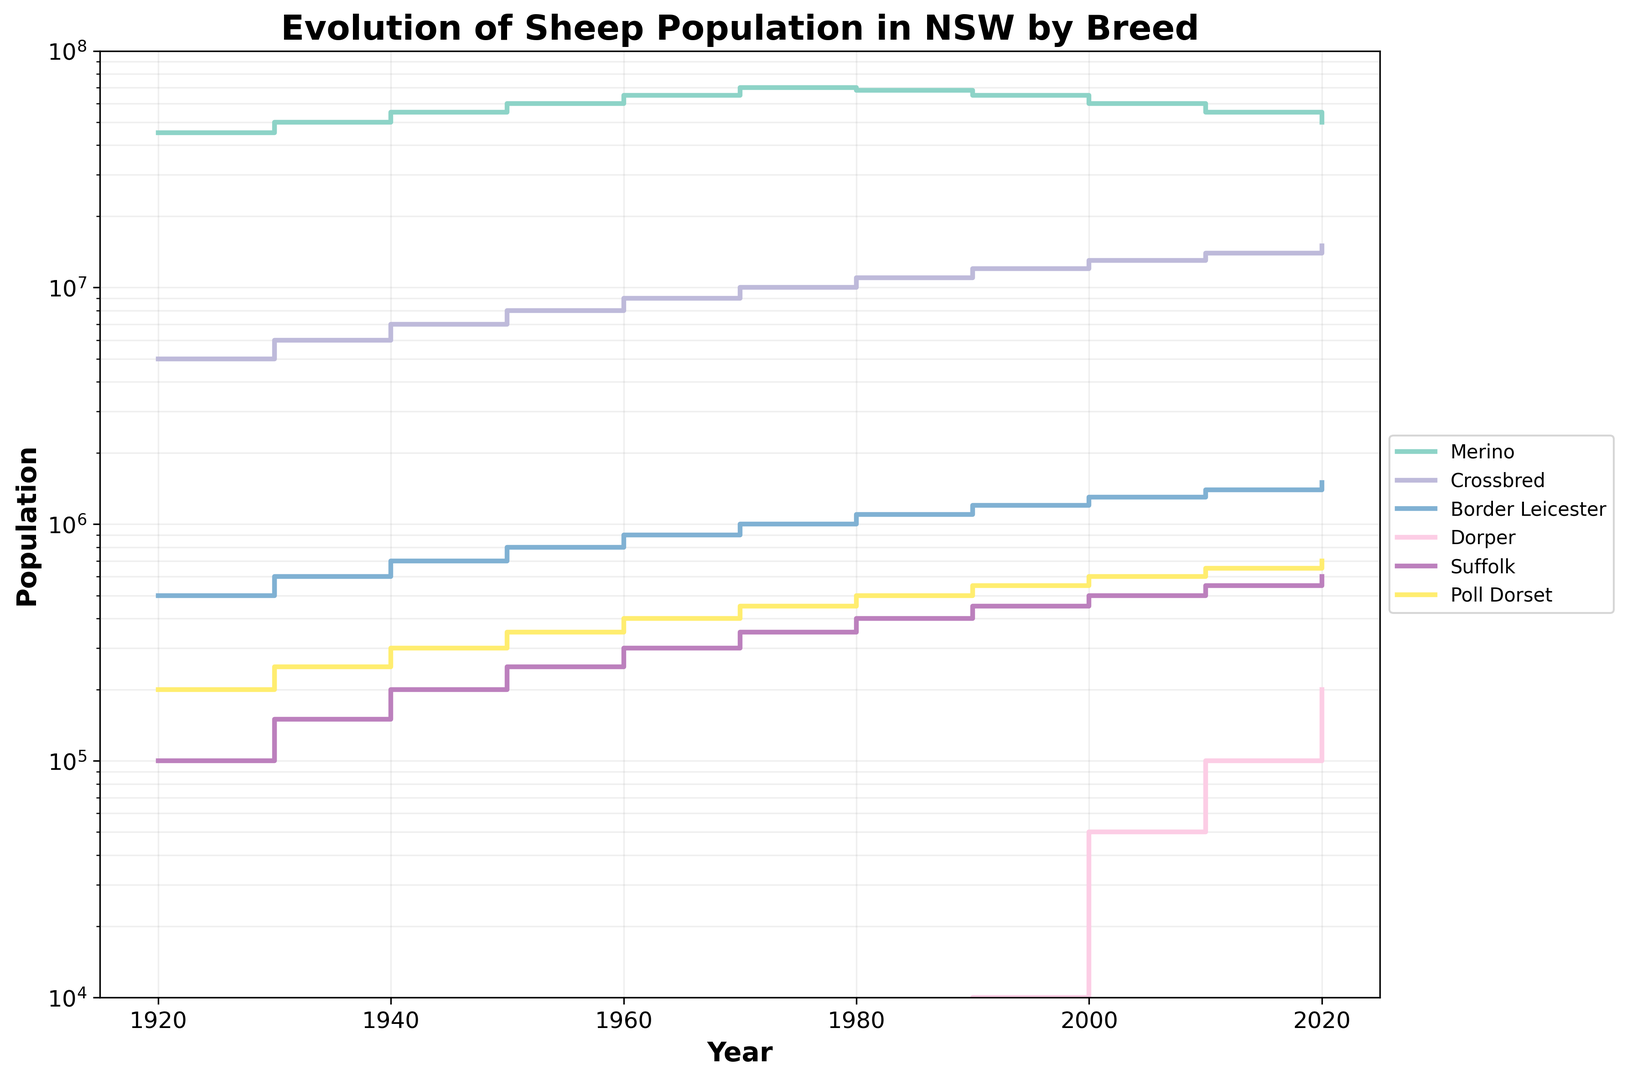What's the population trend of the Merino breed from 1920 to 2020? To understand the Merino population trend, we need to analyze its fluctuations over time. From 1920 to 1970, the population steadily increased. Then, between 1970 and 1980, it experienced a slight decline, followed by a continuing decline till 2020.
Answer: Generally decreasing after 1970 Which breed had the most significant population increase from 1920 to 2020? To determine this, we should calculate the population change for each breed. For instance, the Merino went from 45 million to 50 million, a 5 million increase. The Crossbred went from 5 million to 15 million, a 10 million increase. Comparing all breeds, the Crossbred had the largest increase of 10 million.
Answer: Crossbred In which decade did the Border Leicester breed first appear in the data? To find out when the Border Leicester breed first appears, we should look for the first non-zero value in its population data. The first non-zero value is recorded in 1920.
Answer: 1920 Given the population changes, are there any breeds that did not exist in 1920 but appear later? By checking the 1920 data, neither Dorper nor Poll Dorset had any population recorded. They first appear later, with Dorper starting in 1990 and Poll Dorset present from 1920.
Answer: Dorper How does the population of the Suffolk breed in 2020 compare to 1980? We need to compare the Suffolk population in 1980 (400,000) against its population in 2020 (600,000). To do this, we subtract the 1980 population from the 2020 population to find the increase.
Answer: Increased by 200,000 What is the average population of the Crossbred breed between 1920 and 2020? To calculate the average population of the Crossbred breed, sum the populations from each decade and divide by the number of decades (11). The sum is (5M+6M+7M+8M+9M+10M+11M+12M+13M+14M+15M) = 100M, then divide by 11.
Answer: 9,090,909 Which breed saw its population peak in 1970 and subsequently decline? We look at each breed's population at the 1970 mark and see if their subsequent population declined. Both the Merino peaked at 70 million in 1970 and then declined.
Answer: Merino How does the population of the Poll Dorset in the first half of the century (1920-1970) compare to the second half (1970-2020)? For the Poll Dorset, sum the populations from 1920 to 1970 and from 1970 to 2020. The populations are zero in 1920-1970, and post-1970 it's 450K + 500K + 550K + 600K + 650K + 700K = 3450K.
Answer: Increased Which breed had a steady increase without any period of decline from 1920 to 2020? By examining each breed, we can see that without any decline between years, Crossbred exhibited a steady increase throughout all recorded decades.
Answer: Crossbred 